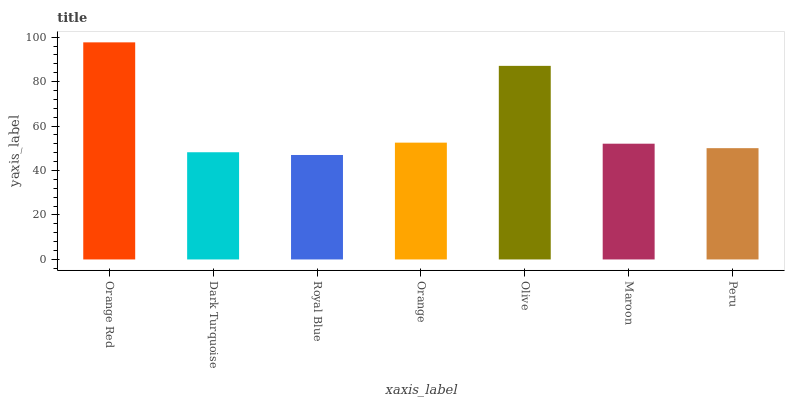Is Royal Blue the minimum?
Answer yes or no. Yes. Is Orange Red the maximum?
Answer yes or no. Yes. Is Dark Turquoise the minimum?
Answer yes or no. No. Is Dark Turquoise the maximum?
Answer yes or no. No. Is Orange Red greater than Dark Turquoise?
Answer yes or no. Yes. Is Dark Turquoise less than Orange Red?
Answer yes or no. Yes. Is Dark Turquoise greater than Orange Red?
Answer yes or no. No. Is Orange Red less than Dark Turquoise?
Answer yes or no. No. Is Maroon the high median?
Answer yes or no. Yes. Is Maroon the low median?
Answer yes or no. Yes. Is Royal Blue the high median?
Answer yes or no. No. Is Olive the low median?
Answer yes or no. No. 